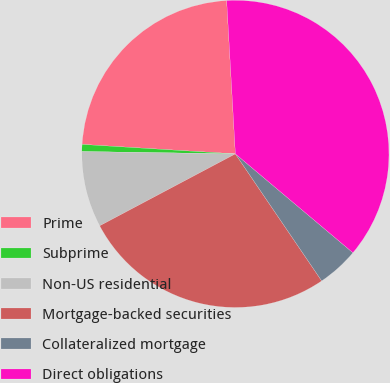Convert chart. <chart><loc_0><loc_0><loc_500><loc_500><pie_chart><fcel>Prime<fcel>Subprime<fcel>Non-US residential<fcel>Mortgage-backed securities<fcel>Collateralized mortgage<fcel>Direct obligations<nl><fcel>23.11%<fcel>0.74%<fcel>8.0%<fcel>26.74%<fcel>4.37%<fcel>37.03%<nl></chart> 